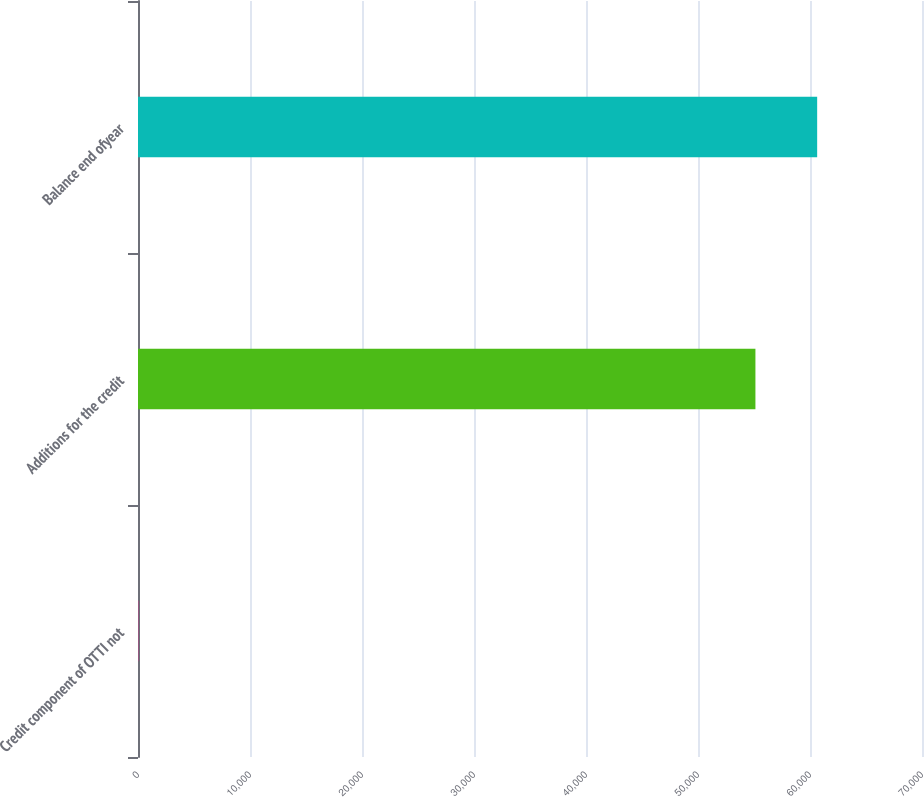Convert chart to OTSL. <chart><loc_0><loc_0><loc_500><loc_500><bar_chart><fcel>Credit component of OTTI not<fcel>Additions for the credit<fcel>Balance end ofyear<nl><fcel>24<fcel>55127<fcel>60639.7<nl></chart> 